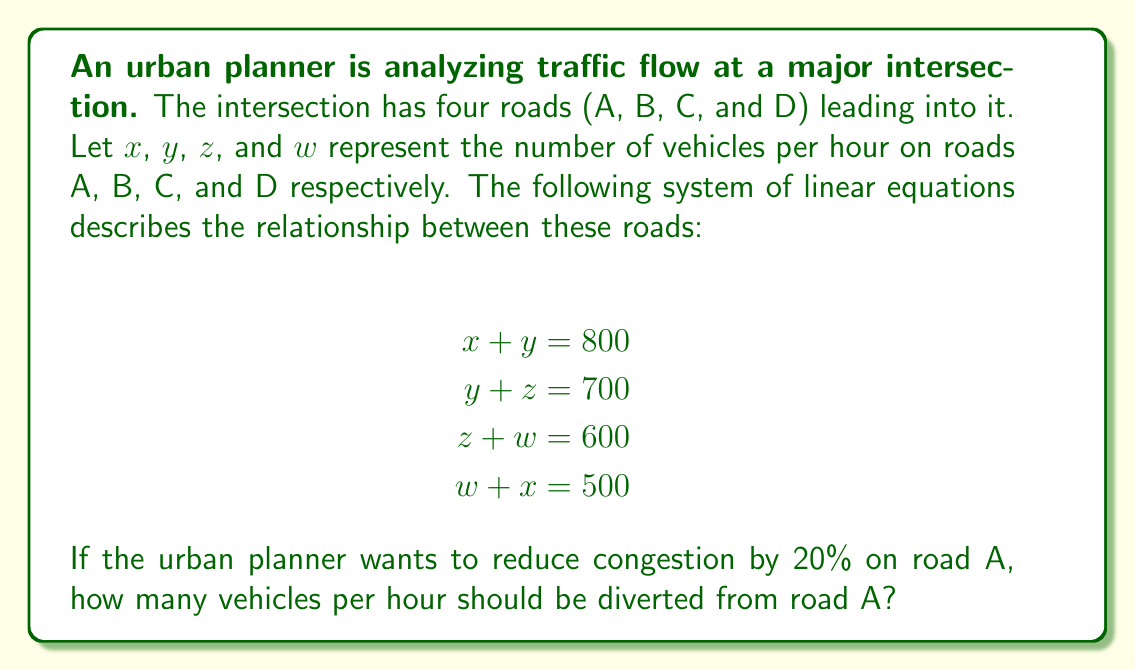Provide a solution to this math problem. Let's solve this problem step by step:

1) First, we need to solve the system of linear equations to find the current number of vehicles on each road.

2) We can solve this by substitution:
   From equation 1: $y = 800 - x$
   Substituting into equation 2: $(800 - x) + z = 700$
   So, $z = x - 100$

3) Substituting $z$ into equation 3:
   $(x - 100) + w = 600$
   $w = 700 - x$

4) Now, substituting $w$ into equation 4:
   $(700 - x) + x = 500$
   $700 = 500$
   This is always true, so our equations are consistent.

5) We can choose any value for $x$ that satisfies all equations. Let's use equation 4:
   $w + x = 500$
   $(700 - x) + x = 500$
   $700 = 500$
   So, $x = 250$ and $w = 250$

6) We can now find $y$ and $z$:
   $y = 800 - x = 800 - 250 = 550$
   $z = x - 100 = 250 - 100 = 150$

7) We've found that currently, there are 250 vehicles per hour on road A.

8) To reduce this by 20%, we calculate:
   $250 * 0.20 = 50$

Therefore, 50 vehicles per hour should be diverted from road A to reduce congestion by 20%.
Answer: 50 vehicles per hour 